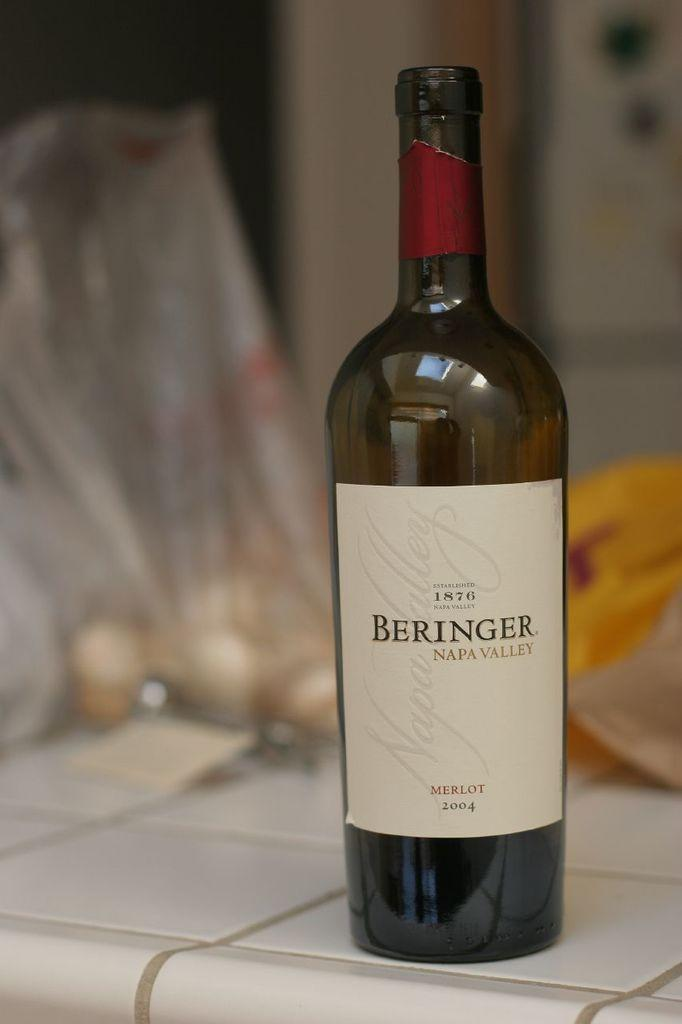Provide a one-sentence caption for the provided image. bottle of merlot beringer wine on a white tile counter top. 